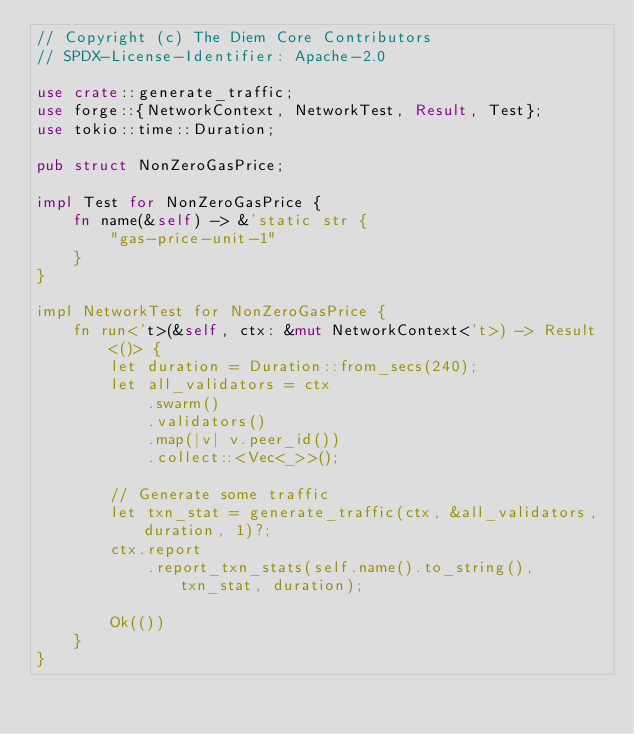Convert code to text. <code><loc_0><loc_0><loc_500><loc_500><_Rust_>// Copyright (c) The Diem Core Contributors
// SPDX-License-Identifier: Apache-2.0

use crate::generate_traffic;
use forge::{NetworkContext, NetworkTest, Result, Test};
use tokio::time::Duration;

pub struct NonZeroGasPrice;

impl Test for NonZeroGasPrice {
    fn name(&self) -> &'static str {
        "gas-price-unit-1"
    }
}

impl NetworkTest for NonZeroGasPrice {
    fn run<'t>(&self, ctx: &mut NetworkContext<'t>) -> Result<()> {
        let duration = Duration::from_secs(240);
        let all_validators = ctx
            .swarm()
            .validators()
            .map(|v| v.peer_id())
            .collect::<Vec<_>>();

        // Generate some traffic
        let txn_stat = generate_traffic(ctx, &all_validators, duration, 1)?;
        ctx.report
            .report_txn_stats(self.name().to_string(), txn_stat, duration);

        Ok(())
    }
}
</code> 